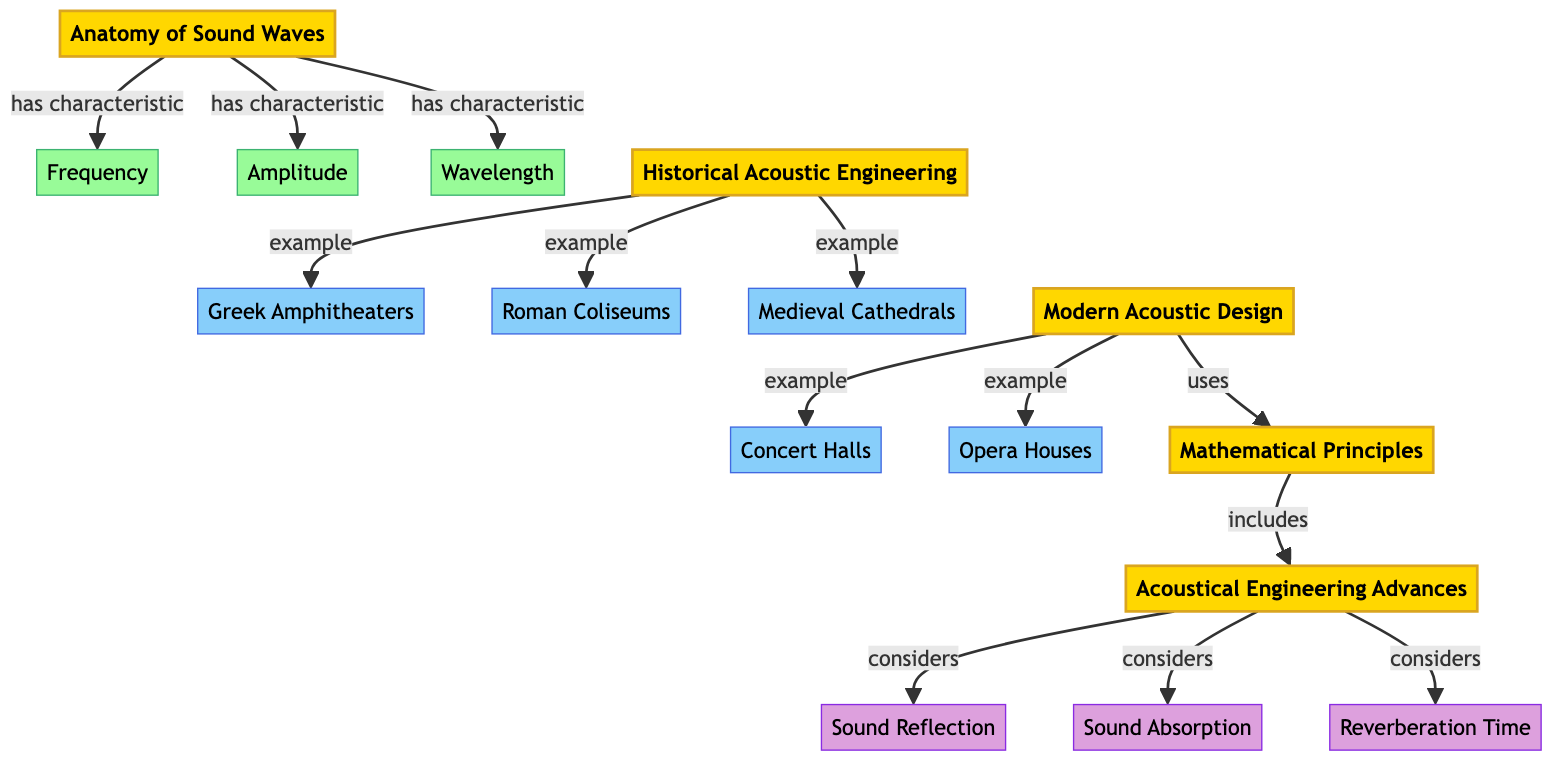What are the three characteristics of sound waves? The diagram lists three characteristics under the "Anatomy of Sound Waves" node: Frequency, Amplitude, and Wavelength.
Answer: Frequency, Amplitude, Wavelength How many examples of historical acoustic engineering are mentioned? The diagram lists three specific examples: Greek Amphitheaters, Roman Coliseums, and Medieval Cathedrals, indicating a total of three examples under "Historical Acoustic Engineering."
Answer: 3 Which modern examples are associated with acoustic design? The examples listed under "Modern Acoustic Design" include Concert Halls and Opera Houses. Thus, there are two examples associated with modern acoustic design.
Answer: Concert Halls, Opera Houses What consideration factors are involved in acoustical engineering advances? The considerations include Sound Reflection, Sound Absorption, and Reverberation Time, which are indicated as important factors under "Acoustical Engineering Advances."
Answer: Sound Reflection, Sound Absorption, Reverberation Time What is the relationship between modern acoustic design and mathematical principles? The diagram shows a direct connection where Modern Acoustic Design "uses" Mathematical Principles, highlighting the reliance of modern designs on mathematical concepts for effective acoustics.
Answer: uses How many main topics are presented in the diagram? The diagram highlights five main topics: Anatomy of Sound Waves, Historical Acoustic Engineering, Modern Acoustic Design, Mathematical Principles, and Acoustical Engineering Advances, showing a total of five main topics in the diagram.
Answer: 5 What does 'Reverberation Time' belong to in the diagram? The "Reverberation Time" is categorized as a consideration under the "Acoustical Engineering Advances" node, indicating its role as an important factor in acoustic design.
Answer: Acoustical Engineering Advances Which node directly connects the "Greek Amphitheaters" example to the discussion of historical engineering? The "Greek Amphitheaters" node is directly connected as an example under the "Historical Acoustic Engineering" main topic, illustrating how it epitomizes historical advancements in acoustic design.
Answer: Historical Acoustic Engineering 